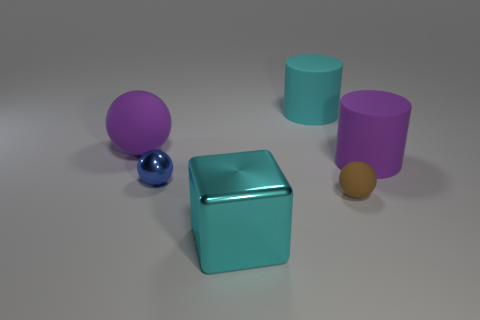There is a thing that is made of the same material as the big cube; what is its color?
Offer a very short reply. Blue. There is a blue ball; is its size the same as the sphere that is in front of the small metal object?
Your response must be concise. Yes. The big cyan object that is in front of the purple rubber object that is behind the large matte object that is right of the large cyan cylinder is made of what material?
Make the answer very short. Metal. What number of things are cyan blocks or rubber objects?
Ensure brevity in your answer.  5. Is the color of the metallic thing that is in front of the tiny blue shiny object the same as the rubber cylinder on the left side of the small brown rubber ball?
Your answer should be very brief. Yes. What shape is the cyan rubber thing that is the same size as the purple rubber cylinder?
Your response must be concise. Cylinder. What number of things are objects that are in front of the large purple rubber ball or large purple things that are on the right side of the cyan block?
Offer a very short reply. 4. Is the number of large green rubber cubes less than the number of purple spheres?
Offer a terse response. Yes. There is another cylinder that is the same size as the purple cylinder; what is it made of?
Keep it short and to the point. Rubber. There is a purple rubber object to the right of the small blue thing; is its size the same as the ball that is to the left of the metal sphere?
Your answer should be compact. Yes. 